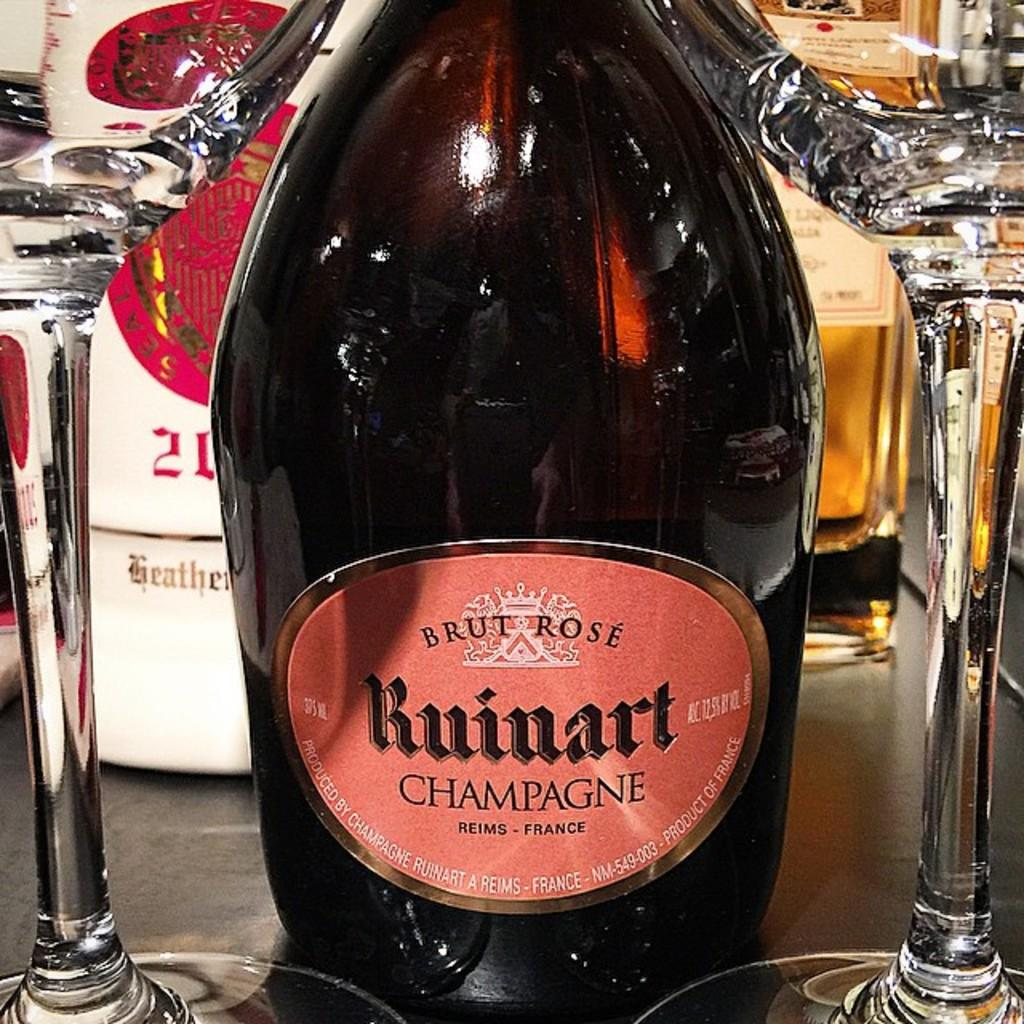<image>
Write a terse but informative summary of the picture. A bottle of champange is resting on a shelf with two glasses. 